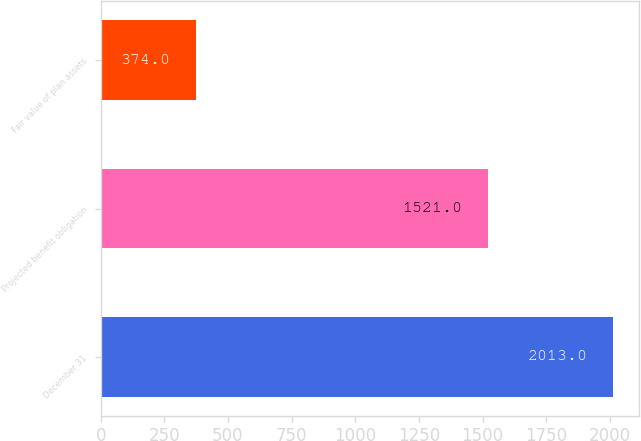Convert chart to OTSL. <chart><loc_0><loc_0><loc_500><loc_500><bar_chart><fcel>December 31<fcel>Projected benefit obligation<fcel>Fair value of plan assets<nl><fcel>2013<fcel>1521<fcel>374<nl></chart> 